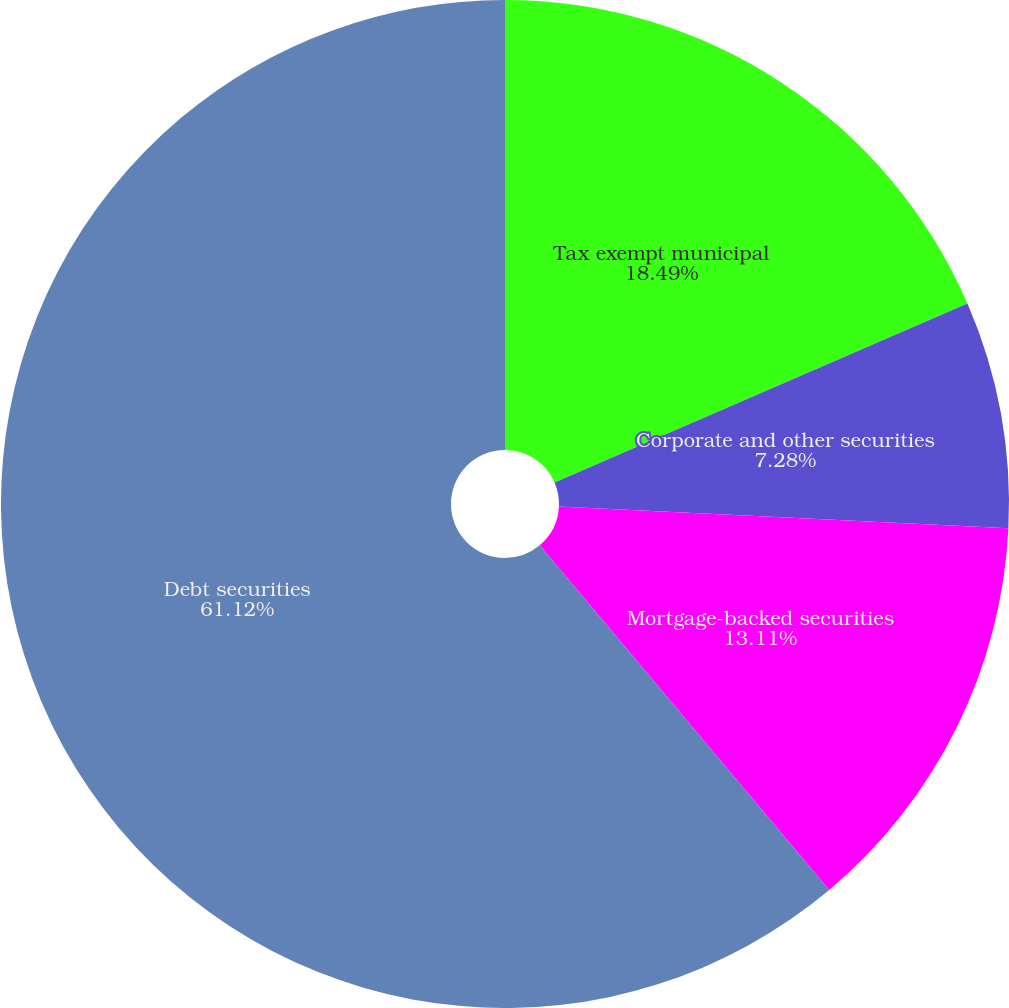<chart> <loc_0><loc_0><loc_500><loc_500><pie_chart><fcel>Tax exempt municipal<fcel>Corporate and other securities<fcel>Mortgage-backed securities<fcel>Debt securities<nl><fcel>18.49%<fcel>7.28%<fcel>13.11%<fcel>61.12%<nl></chart> 